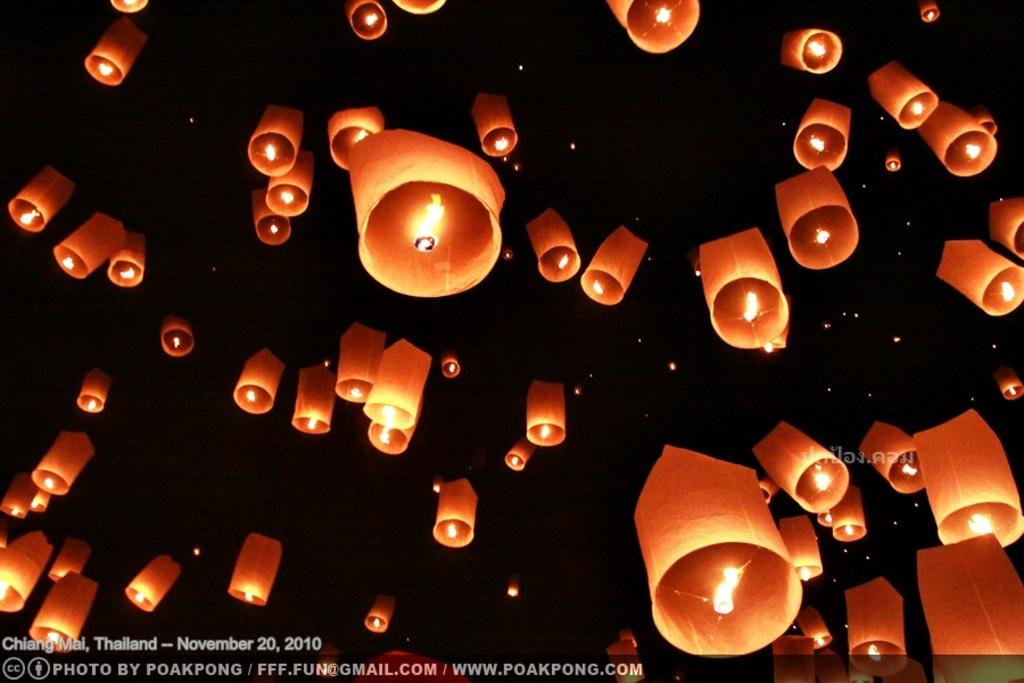What time of day is depicted in the image? The image depicts a night view. What are the floating objects in the image? There are sky lanterns in the image. Is there any text present in the image? Yes, there is some text on the image. What type of sand can be seen on the ground in the image? There is no sand present in the image; it depicts a night view with sky lanterns and text. What color is the dress worn by the owl in the image? There is no owl present in the image, and therefore no dress to describe. 